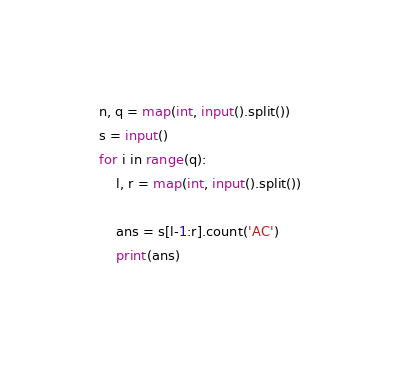<code> <loc_0><loc_0><loc_500><loc_500><_Python_>n, q = map(int, input().split())
s = input()
for i in range(q):
    l, r = map(int, input().split())
    
    ans = s[l-1:r].count('AC')
    print(ans)</code> 